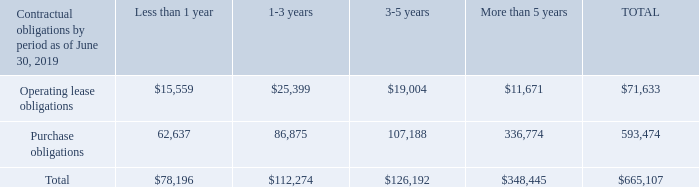OFF-BALANCE SHEET ARRANGEMENTS AND CONTRACTUAL OBLIGATIONS
At June 30, 2019, the Company’s total off-balance sheet contractual obligations were $665,107. This balance consists of $71,633 of long-term operating leases for various facilities and equipment which expire from 2020 to 2030 and $593,474 of purchase commitments. In fiscal 2017, JHA entered a strategic services agreement with First Data® and PSCU® to provide full-service debit and credit card processing on a single platform to all existing core bank and credit union customers, as well as expand its card processing platform to financial institutions outside our core customer base. This agreement includes a purchase commitment of $555,754 over the remaining term of the contract. The remainder of the purchase commitments relate mainly to open purchase orders. The contractual obligations table below excludes $12,009 of liabilities for uncertain tax positions as we are unable to reasonably estimate the ultimate amount or timing of settlement.
The operating lease obligations included on this table will be recorded on the balance sheet beginning in fiscal 2020 due to the Company’s adoption of ASU No. 2016-02, issued by the FASB in February 2016 and effective for the Company on July 1, 2019.
What are the 2 financial items shown in the table? Operating lease obligations, purchase obligations. What is the total operating lease obligations? $71,633. What is the total purchase obligations? 593,474. Between total operating lease obligations and total purchase obligations, which is higher? 593,474>71,633
Answer: purchase obligations. What percentage of total contractual obligations is the total operating lease obligations?
Answer scale should be: percent. $71,633/$665,107
Answer: 10.77. What percentage of total contractual obligations is the total purchase obligations?
Answer scale should be: percent. 593,474/665,107
Answer: 89.23. 